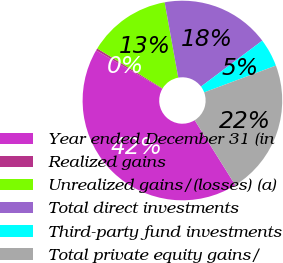Convert chart to OTSL. <chart><loc_0><loc_0><loc_500><loc_500><pie_chart><fcel>Year ended December 31 (in<fcel>Realized gains<fcel>Unrealized gains/(losses) (a)<fcel>Total direct investments<fcel>Third-party fund investments<fcel>Total private equity gains/<nl><fcel>42.26%<fcel>0.36%<fcel>13.42%<fcel>17.61%<fcel>4.55%<fcel>21.8%<nl></chart> 